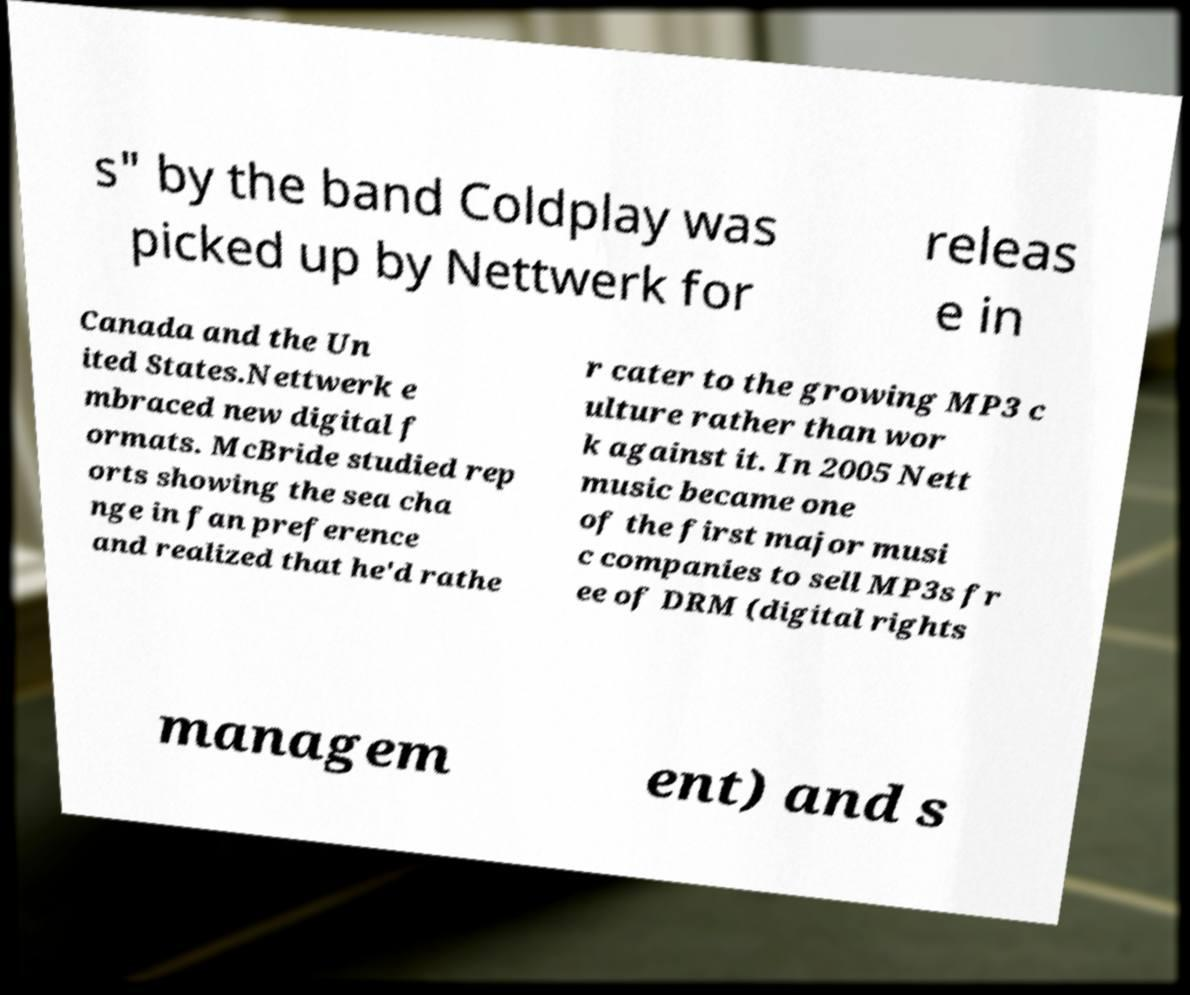Can you accurately transcribe the text from the provided image for me? s" by the band Coldplay was picked up by Nettwerk for releas e in Canada and the Un ited States.Nettwerk e mbraced new digital f ormats. McBride studied rep orts showing the sea cha nge in fan preference and realized that he'd rathe r cater to the growing MP3 c ulture rather than wor k against it. In 2005 Nett music became one of the first major musi c companies to sell MP3s fr ee of DRM (digital rights managem ent) and s 